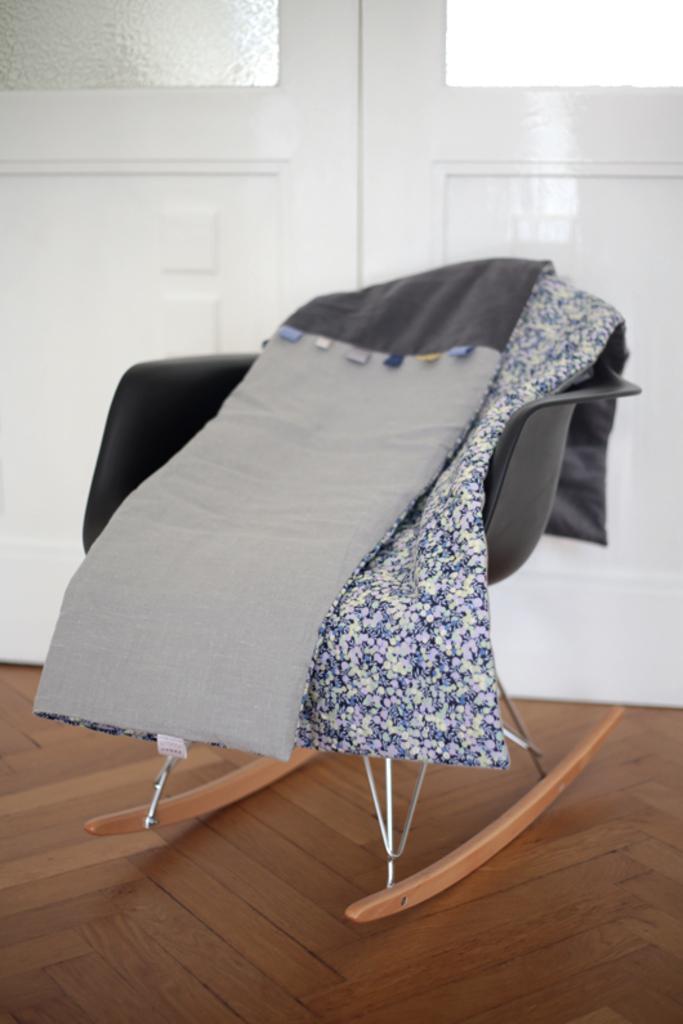Could you give a brief overview of what you see in this image? In this picture we can see some clothes on the chair and the chair is on the wooden floor. Behind the chair there is a door with glasses. 